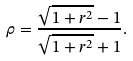<formula> <loc_0><loc_0><loc_500><loc_500>\rho = \frac { \sqrt { 1 + r ^ { 2 } } - 1 } { \sqrt { 1 + r ^ { 2 } } + 1 } .</formula> 